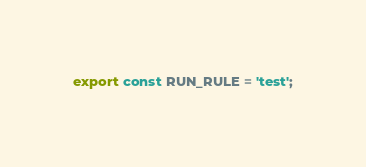Convert code to text. <code><loc_0><loc_0><loc_500><loc_500><_JavaScript_>export const RUN_RULE = 'test';
</code> 